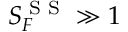<formula> <loc_0><loc_0><loc_500><loc_500>S _ { F } ^ { S S } \gg 1</formula> 